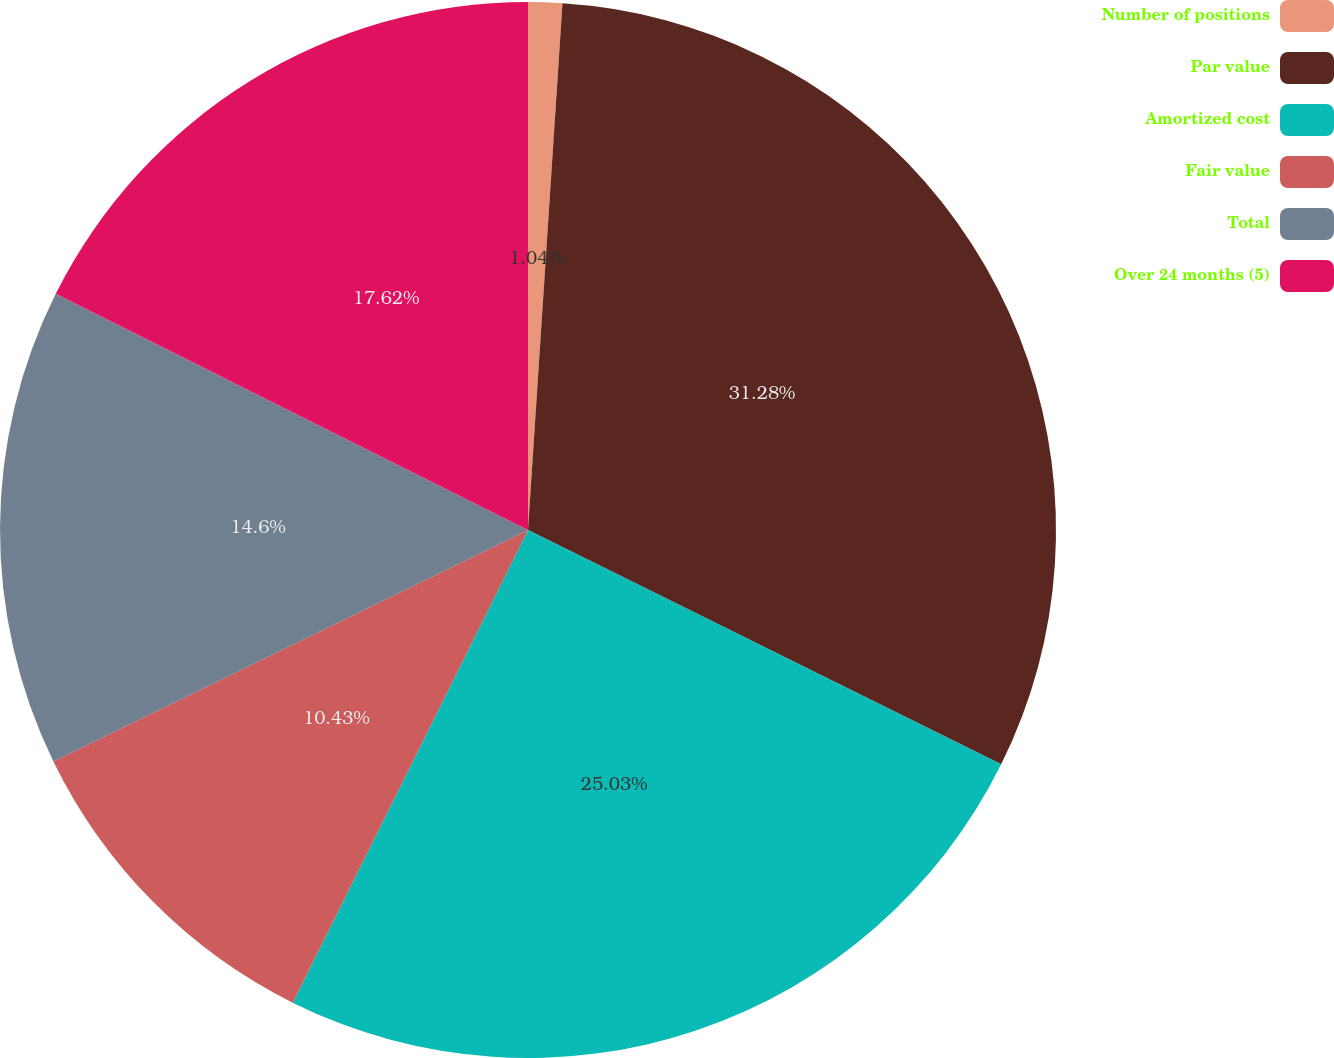<chart> <loc_0><loc_0><loc_500><loc_500><pie_chart><fcel>Number of positions<fcel>Par value<fcel>Amortized cost<fcel>Fair value<fcel>Total<fcel>Over 24 months (5)<nl><fcel>1.04%<fcel>31.28%<fcel>25.03%<fcel>10.43%<fcel>14.6%<fcel>17.62%<nl></chart> 